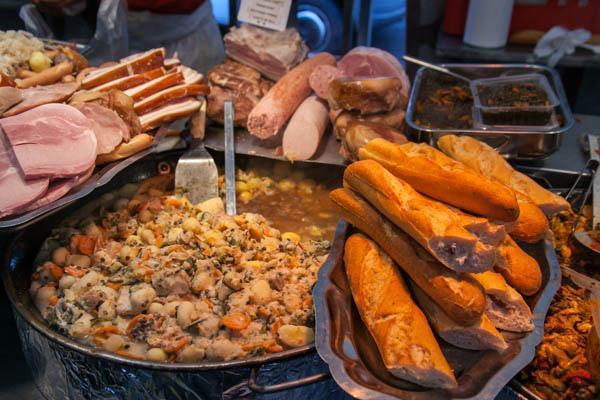How many hot dogs are there?
Give a very brief answer. 8. 